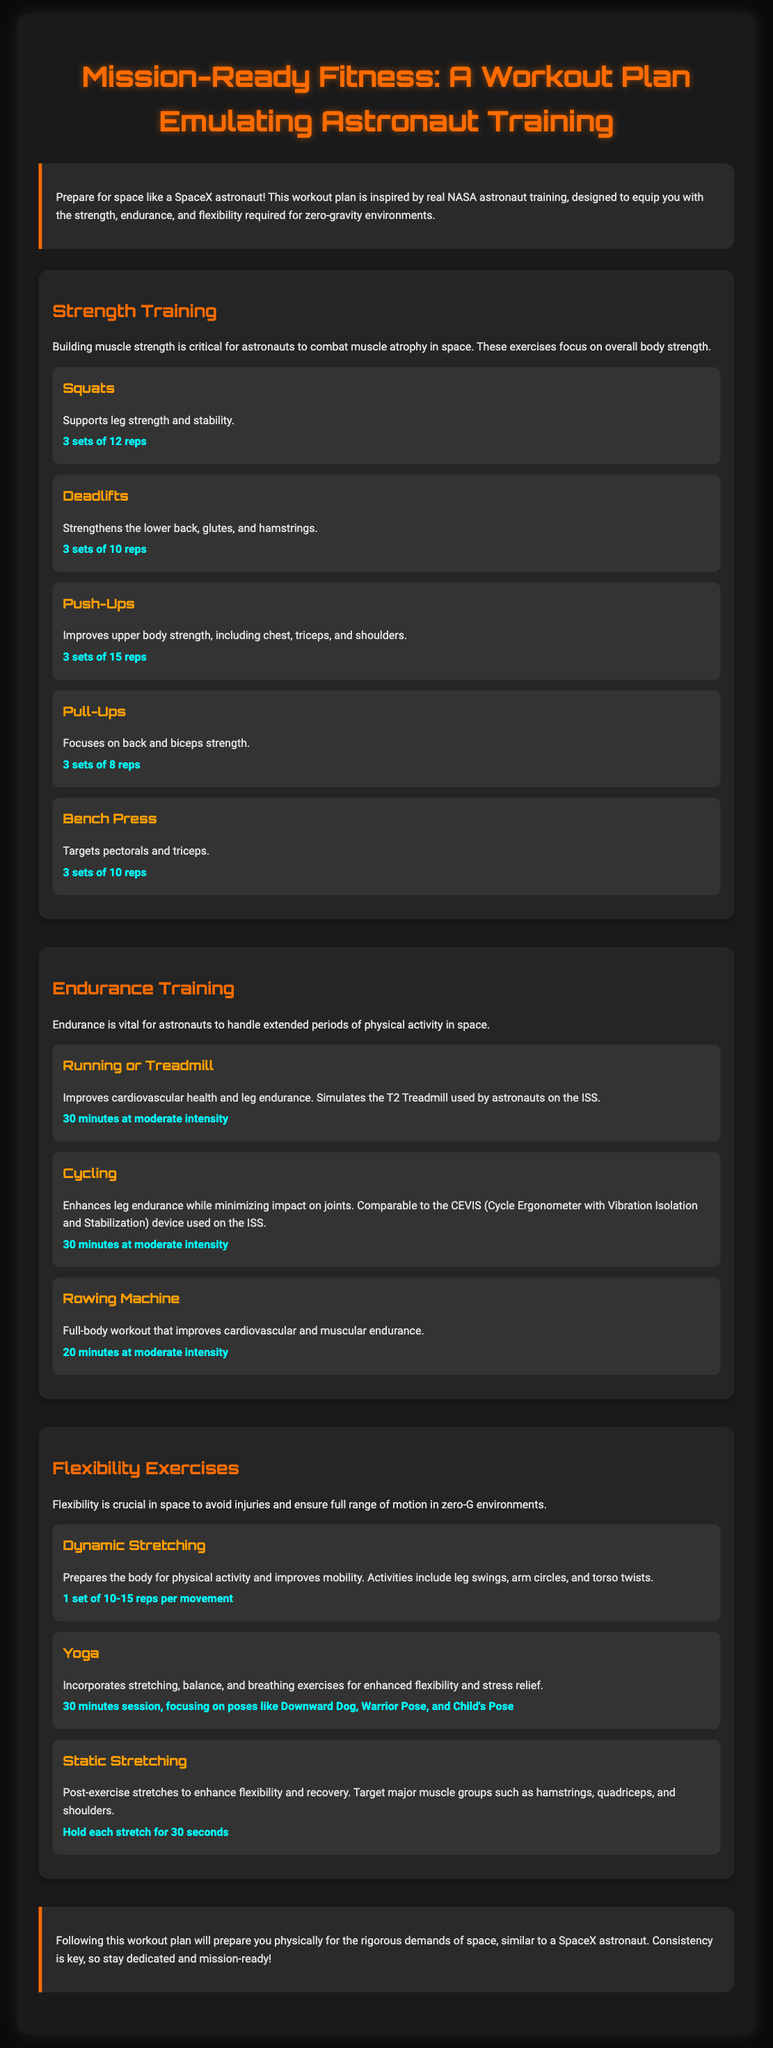What is the title of the workout plan? The title is the main heading of the document, which is "Mission-Ready Fitness: A Workout Plan Emulating Astronaut Training."
Answer: Mission-Ready Fitness: A Workout Plan Emulating Astronaut Training How many sets and reps are recommended for Squats? The sets and reps for Squats are specified under the exercise section for strength training.
Answer: 3 sets of 12 reps What type of training focuses on cardiovascular health and leg endurance? This type is specifically mentioned under the endurance training section, highlighting the need for cardiovascular fitness.
Answer: Endurance Training What is the duration for the Yoga session recommended in the plan? The recommended duration for Yoga is mentioned in the section about flexibility exercises.
Answer: 30 minutes Which exercise targets pectorals and triceps? This is included as one of the strength training exercises in the document.
Answer: Bench Press What is a key benefit of Dynamic Stretching? The document explains the purpose of Dynamic Stretching in preparing the body for activity.
Answer: Prepares the body for physical activity How many minutes of moderate-intensity cycling are included in the endurance training section? This information is stated in the endurance training section, outlining the cycling activity.
Answer: 30 minutes What should be held for 30 seconds according to the flexibility exercises? This is outlined in the static stretching section, detailing the procedure after exercises.
Answer: Each stretch 